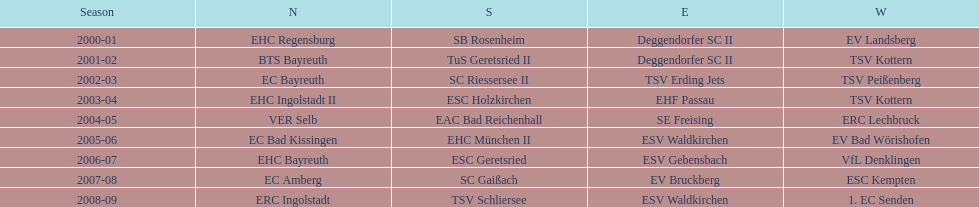The only team to win the north in 2000-01 season? EHC Regensburg. 